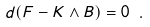<formula> <loc_0><loc_0><loc_500><loc_500>d ( F - K \wedge B ) = 0 \ .</formula> 